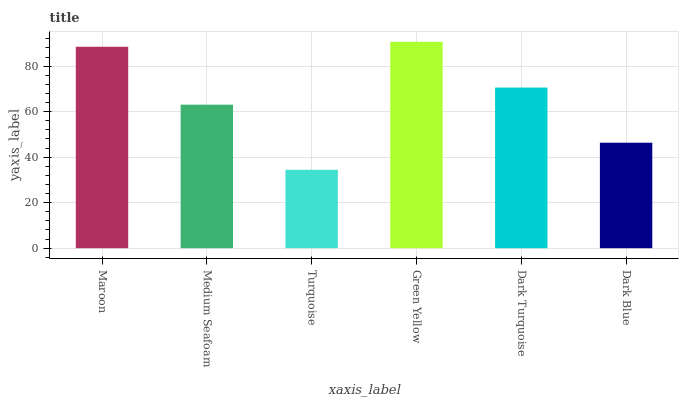Is Turquoise the minimum?
Answer yes or no. Yes. Is Green Yellow the maximum?
Answer yes or no. Yes. Is Medium Seafoam the minimum?
Answer yes or no. No. Is Medium Seafoam the maximum?
Answer yes or no. No. Is Maroon greater than Medium Seafoam?
Answer yes or no. Yes. Is Medium Seafoam less than Maroon?
Answer yes or no. Yes. Is Medium Seafoam greater than Maroon?
Answer yes or no. No. Is Maroon less than Medium Seafoam?
Answer yes or no. No. Is Dark Turquoise the high median?
Answer yes or no. Yes. Is Medium Seafoam the low median?
Answer yes or no. Yes. Is Dark Blue the high median?
Answer yes or no. No. Is Dark Turquoise the low median?
Answer yes or no. No. 